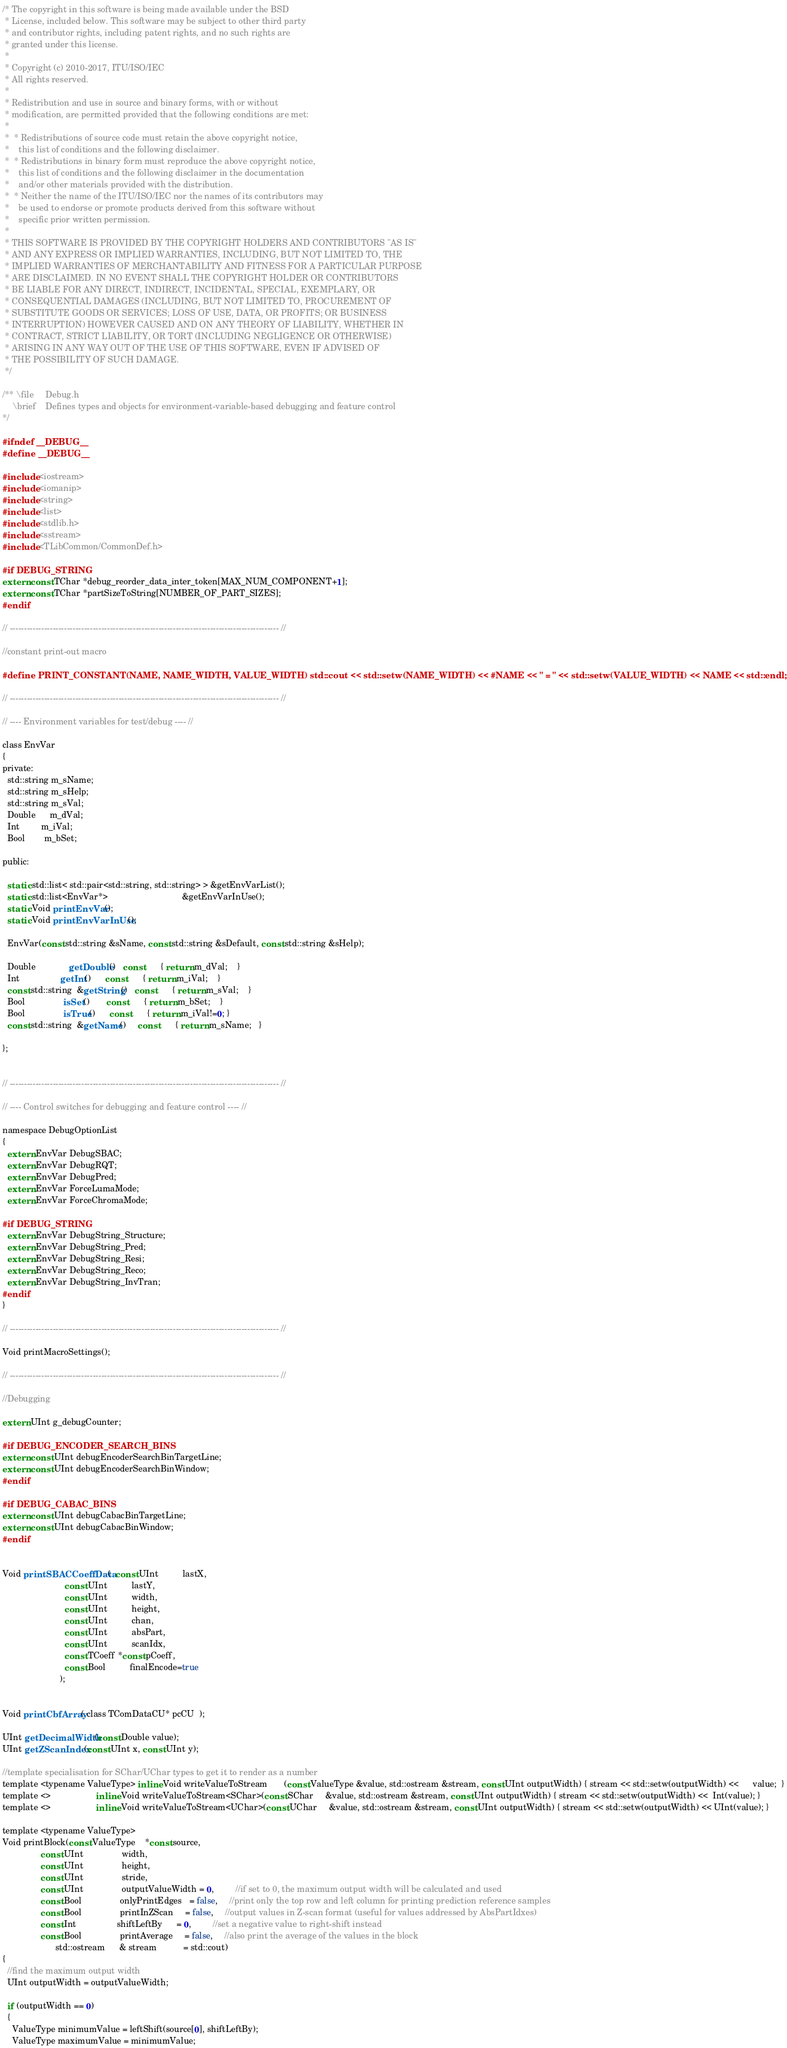<code> <loc_0><loc_0><loc_500><loc_500><_C_>/* The copyright in this software is being made available under the BSD
 * License, included below. This software may be subject to other third party
 * and contributor rights, including patent rights, and no such rights are
 * granted under this license.
 *
 * Copyright (c) 2010-2017, ITU/ISO/IEC
 * All rights reserved.
 *
 * Redistribution and use in source and binary forms, with or without
 * modification, are permitted provided that the following conditions are met:
 *
 *  * Redistributions of source code must retain the above copyright notice,
 *    this list of conditions and the following disclaimer.
 *  * Redistributions in binary form must reproduce the above copyright notice,
 *    this list of conditions and the following disclaimer in the documentation
 *    and/or other materials provided with the distribution.
 *  * Neither the name of the ITU/ISO/IEC nor the names of its contributors may
 *    be used to endorse or promote products derived from this software without
 *    specific prior written permission.
 *
 * THIS SOFTWARE IS PROVIDED BY THE COPYRIGHT HOLDERS AND CONTRIBUTORS "AS IS"
 * AND ANY EXPRESS OR IMPLIED WARRANTIES, INCLUDING, BUT NOT LIMITED TO, THE
 * IMPLIED WARRANTIES OF MERCHANTABILITY AND FITNESS FOR A PARTICULAR PURPOSE
 * ARE DISCLAIMED. IN NO EVENT SHALL THE COPYRIGHT HOLDER OR CONTRIBUTORS
 * BE LIABLE FOR ANY DIRECT, INDIRECT, INCIDENTAL, SPECIAL, EXEMPLARY, OR
 * CONSEQUENTIAL DAMAGES (INCLUDING, BUT NOT LIMITED TO, PROCUREMENT OF
 * SUBSTITUTE GOODS OR SERVICES; LOSS OF USE, DATA, OR PROFITS; OR BUSINESS
 * INTERRUPTION) HOWEVER CAUSED AND ON ANY THEORY OF LIABILITY, WHETHER IN
 * CONTRACT, STRICT LIABILITY, OR TORT (INCLUDING NEGLIGENCE OR OTHERWISE)
 * ARISING IN ANY WAY OUT OF THE USE OF THIS SOFTWARE, EVEN IF ADVISED OF
 * THE POSSIBILITY OF SUCH DAMAGE.
 */

/** \file     Debug.h
    \brief    Defines types and objects for environment-variable-based debugging and feature control
*/

#ifndef __DEBUG__
#define __DEBUG__

#include <iostream>
#include <iomanip>
#include <string>
#include <list>
#include <stdlib.h>
#include <sstream>
#include <TLibCommon/CommonDef.h>

#if DEBUG_STRING
extern const TChar *debug_reorder_data_inter_token[MAX_NUM_COMPONENT+1];
extern const TChar *partSizeToString[NUMBER_OF_PART_SIZES];
#endif

// ---------------------------------------------------------------------------------------------- //

//constant print-out macro

#define PRINT_CONSTANT(NAME, NAME_WIDTH, VALUE_WIDTH) std::cout << std::setw(NAME_WIDTH) << #NAME << " = " << std::setw(VALUE_WIDTH) << NAME << std::endl;

// ---------------------------------------------------------------------------------------------- //

// ---- Environment variables for test/debug ---- //

class EnvVar
{
private:
  std::string m_sName;
  std::string m_sHelp;
  std::string m_sVal;
  Double      m_dVal;
  Int         m_iVal;
  Bool        m_bSet;

public:

  static std::list< std::pair<std::string, std::string> > &getEnvVarList();
  static std::list<EnvVar*>                               &getEnvVarInUse();
  static Void printEnvVar();
  static Void printEnvVarInUse();

  EnvVar(const std::string &sName, const std::string &sDefault, const std::string &sHelp);

  Double              getDouble()   const       { return m_dVal;    }
  Int                 getInt()      const       { return m_iVal;    }
  const std::string  &getString()   const       { return m_sVal;    }
  Bool                isSet()       const       { return m_bSet;    }
  Bool                isTrue()      const       { return m_iVal!=0; }
  const std::string  &getName()     const       { return m_sName;   }

};


// ---------------------------------------------------------------------------------------------- //

// ---- Control switches for debugging and feature control ---- //

namespace DebugOptionList
{
  extern EnvVar DebugSBAC;
  extern EnvVar DebugRQT;
  extern EnvVar DebugPred;
  extern EnvVar ForceLumaMode;
  extern EnvVar ForceChromaMode;

#if DEBUG_STRING
  extern EnvVar DebugString_Structure;
  extern EnvVar DebugString_Pred;
  extern EnvVar DebugString_Resi;
  extern EnvVar DebugString_Reco;
  extern EnvVar DebugString_InvTran;
#endif
}

// ---------------------------------------------------------------------------------------------- //

Void printMacroSettings();

// ---------------------------------------------------------------------------------------------- //

//Debugging

extern UInt g_debugCounter;

#if DEBUG_ENCODER_SEARCH_BINS
extern const UInt debugEncoderSearchBinTargetLine;
extern const UInt debugEncoderSearchBinWindow;
#endif

#if DEBUG_CABAC_BINS
extern const UInt debugCabacBinTargetLine;
extern const UInt debugCabacBinWindow;
#endif


Void printSBACCoeffData(  const UInt          lastX,
                          const UInt          lastY,
                          const UInt          width,
                          const UInt          height,
                          const UInt          chan,
                          const UInt          absPart,
                          const UInt          scanIdx,
                          const TCoeff *const pCoeff,
                          const Bool          finalEncode=true
                        );


Void printCbfArray( class TComDataCU* pcCU  );

UInt getDecimalWidth(const Double value);
UInt getZScanIndex(const UInt x, const UInt y);

//template specialisation for SChar/UChar types to get it to render as a number
template <typename ValueType> inline Void writeValueToStream       (const ValueType &value, std::ostream &stream, const UInt outputWidth) { stream << std::setw(outputWidth) <<      value;  }
template <>                   inline Void writeValueToStream<SChar>(const SChar     &value, std::ostream &stream, const UInt outputWidth) { stream << std::setw(outputWidth) <<  Int(value); }
template <>                   inline Void writeValueToStream<UChar>(const UChar     &value, std::ostream &stream, const UInt outputWidth) { stream << std::setw(outputWidth) << UInt(value); }

template <typename ValueType>
Void printBlock(const ValueType    *const source,
                const UInt                width,
                const UInt                height,
                const UInt                stride,
                const UInt                outputValueWidth = 0,         //if set to 0, the maximum output width will be calculated and used
                const Bool                onlyPrintEdges   = false,     //print only the top row and left column for printing prediction reference samples
                const Bool                printInZScan     = false,     //output values in Z-scan format (useful for values addressed by AbsPartIdxes)
                const Int                 shiftLeftBy      = 0,         //set a negative value to right-shift instead
                const Bool                printAverage     = false,     //also print the average of the values in the block
                      std::ostream      & stream           = std::cout)
{
  //find the maximum output width
  UInt outputWidth = outputValueWidth;

  if (outputWidth == 0)
  {
    ValueType minimumValue = leftShift(source[0], shiftLeftBy);
    ValueType maximumValue = minimumValue;
</code> 